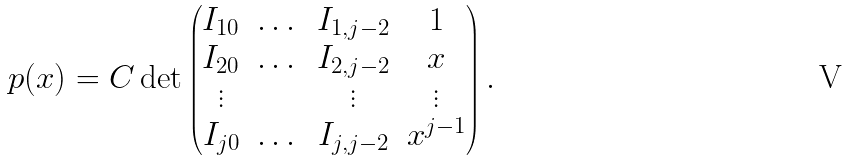<formula> <loc_0><loc_0><loc_500><loc_500>p ( x ) = C \det \begin{pmatrix} I _ { 1 0 } & \dots & I _ { 1 , j - 2 } & 1 \\ I _ { 2 0 } & \dots & I _ { 2 , j - 2 } & x \\ \vdots & & \vdots & \vdots \\ I _ { j 0 } & \dots & I _ { j , j - 2 } & x ^ { j - 1 } \\ \end{pmatrix} .</formula> 